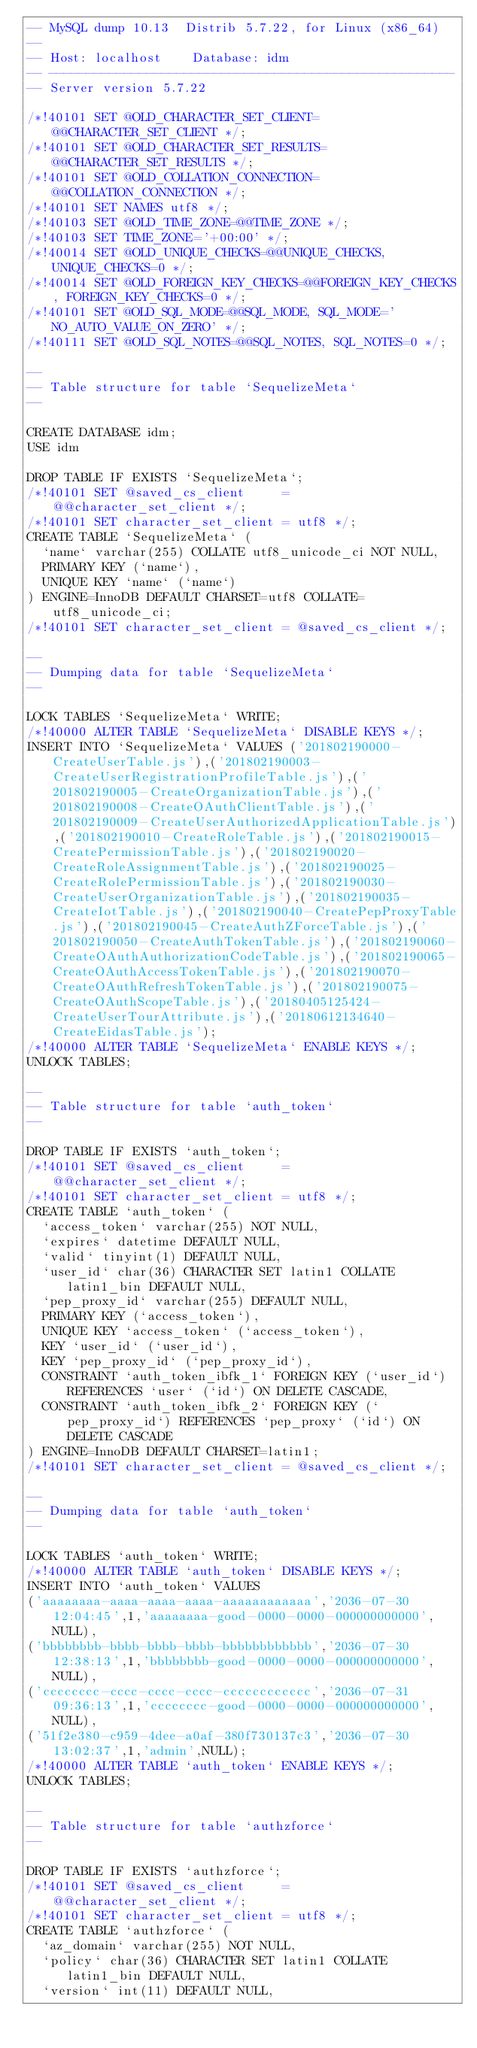Convert code to text. <code><loc_0><loc_0><loc_500><loc_500><_SQL_>-- MySQL dump 10.13  Distrib 5.7.22, for Linux (x86_64)
--
-- Host: localhost    Database: idm
-- ------------------------------------------------------
-- Server version 5.7.22

/*!40101 SET @OLD_CHARACTER_SET_CLIENT=@@CHARACTER_SET_CLIENT */;
/*!40101 SET @OLD_CHARACTER_SET_RESULTS=@@CHARACTER_SET_RESULTS */;
/*!40101 SET @OLD_COLLATION_CONNECTION=@@COLLATION_CONNECTION */;
/*!40101 SET NAMES utf8 */;
/*!40103 SET @OLD_TIME_ZONE=@@TIME_ZONE */;
/*!40103 SET TIME_ZONE='+00:00' */;
/*!40014 SET @OLD_UNIQUE_CHECKS=@@UNIQUE_CHECKS, UNIQUE_CHECKS=0 */;
/*!40014 SET @OLD_FOREIGN_KEY_CHECKS=@@FOREIGN_KEY_CHECKS, FOREIGN_KEY_CHECKS=0 */;
/*!40101 SET @OLD_SQL_MODE=@@SQL_MODE, SQL_MODE='NO_AUTO_VALUE_ON_ZERO' */;
/*!40111 SET @OLD_SQL_NOTES=@@SQL_NOTES, SQL_NOTES=0 */;

--
-- Table structure for table `SequelizeMeta`
--

CREATE DATABASE idm;
USE idm

DROP TABLE IF EXISTS `SequelizeMeta`;
/*!40101 SET @saved_cs_client     = @@character_set_client */;
/*!40101 SET character_set_client = utf8 */;
CREATE TABLE `SequelizeMeta` (
  `name` varchar(255) COLLATE utf8_unicode_ci NOT NULL,
  PRIMARY KEY (`name`),
  UNIQUE KEY `name` (`name`)
) ENGINE=InnoDB DEFAULT CHARSET=utf8 COLLATE=utf8_unicode_ci;
/*!40101 SET character_set_client = @saved_cs_client */;

--
-- Dumping data for table `SequelizeMeta`
--

LOCK TABLES `SequelizeMeta` WRITE;
/*!40000 ALTER TABLE `SequelizeMeta` DISABLE KEYS */;
INSERT INTO `SequelizeMeta` VALUES ('201802190000-CreateUserTable.js'),('201802190003-CreateUserRegistrationProfileTable.js'),('201802190005-CreateOrganizationTable.js'),('201802190008-CreateOAuthClientTable.js'),('201802190009-CreateUserAuthorizedApplicationTable.js'),('201802190010-CreateRoleTable.js'),('201802190015-CreatePermissionTable.js'),('201802190020-CreateRoleAssignmentTable.js'),('201802190025-CreateRolePermissionTable.js'),('201802190030-CreateUserOrganizationTable.js'),('201802190035-CreateIotTable.js'),('201802190040-CreatePepProxyTable.js'),('201802190045-CreateAuthZForceTable.js'),('201802190050-CreateAuthTokenTable.js'),('201802190060-CreateOAuthAuthorizationCodeTable.js'),('201802190065-CreateOAuthAccessTokenTable.js'),('201802190070-CreateOAuthRefreshTokenTable.js'),('201802190075-CreateOAuthScopeTable.js'),('20180405125424-CreateUserTourAttribute.js'),('20180612134640-CreateEidasTable.js');
/*!40000 ALTER TABLE `SequelizeMeta` ENABLE KEYS */;
UNLOCK TABLES;

--
-- Table structure for table `auth_token`
--

DROP TABLE IF EXISTS `auth_token`;
/*!40101 SET @saved_cs_client     = @@character_set_client */;
/*!40101 SET character_set_client = utf8 */;
CREATE TABLE `auth_token` (
  `access_token` varchar(255) NOT NULL,
  `expires` datetime DEFAULT NULL,
  `valid` tinyint(1) DEFAULT NULL,
  `user_id` char(36) CHARACTER SET latin1 COLLATE latin1_bin DEFAULT NULL,
  `pep_proxy_id` varchar(255) DEFAULT NULL,
  PRIMARY KEY (`access_token`),
  UNIQUE KEY `access_token` (`access_token`),
  KEY `user_id` (`user_id`),
  KEY `pep_proxy_id` (`pep_proxy_id`),
  CONSTRAINT `auth_token_ibfk_1` FOREIGN KEY (`user_id`) REFERENCES `user` (`id`) ON DELETE CASCADE,
  CONSTRAINT `auth_token_ibfk_2` FOREIGN KEY (`pep_proxy_id`) REFERENCES `pep_proxy` (`id`) ON DELETE CASCADE
) ENGINE=InnoDB DEFAULT CHARSET=latin1;
/*!40101 SET character_set_client = @saved_cs_client */;

--
-- Dumping data for table `auth_token`
--

LOCK TABLES `auth_token` WRITE;
/*!40000 ALTER TABLE `auth_token` DISABLE KEYS */;
INSERT INTO `auth_token` VALUES 
('aaaaaaaa-aaaa-aaaa-aaaa-aaaaaaaaaaaa','2036-07-30 12:04:45',1,'aaaaaaaa-good-0000-0000-000000000000',NULL),
('bbbbbbbb-bbbb-bbbb-bbbb-bbbbbbbbbbbb','2036-07-30 12:38:13',1,'bbbbbbbb-good-0000-0000-000000000000',NULL),
('cccccccc-cccc-cccc-cccc-cccccccccccc','2036-07-31 09:36:13',1,'cccccccc-good-0000-0000-000000000000',NULL),
('51f2e380-c959-4dee-a0af-380f730137c3','2036-07-30 13:02:37',1,'admin',NULL);
/*!40000 ALTER TABLE `auth_token` ENABLE KEYS */;
UNLOCK TABLES;

--
-- Table structure for table `authzforce`
--

DROP TABLE IF EXISTS `authzforce`;
/*!40101 SET @saved_cs_client     = @@character_set_client */;
/*!40101 SET character_set_client = utf8 */;
CREATE TABLE `authzforce` (
  `az_domain` varchar(255) NOT NULL,
  `policy` char(36) CHARACTER SET latin1 COLLATE latin1_bin DEFAULT NULL,
  `version` int(11) DEFAULT NULL,</code> 